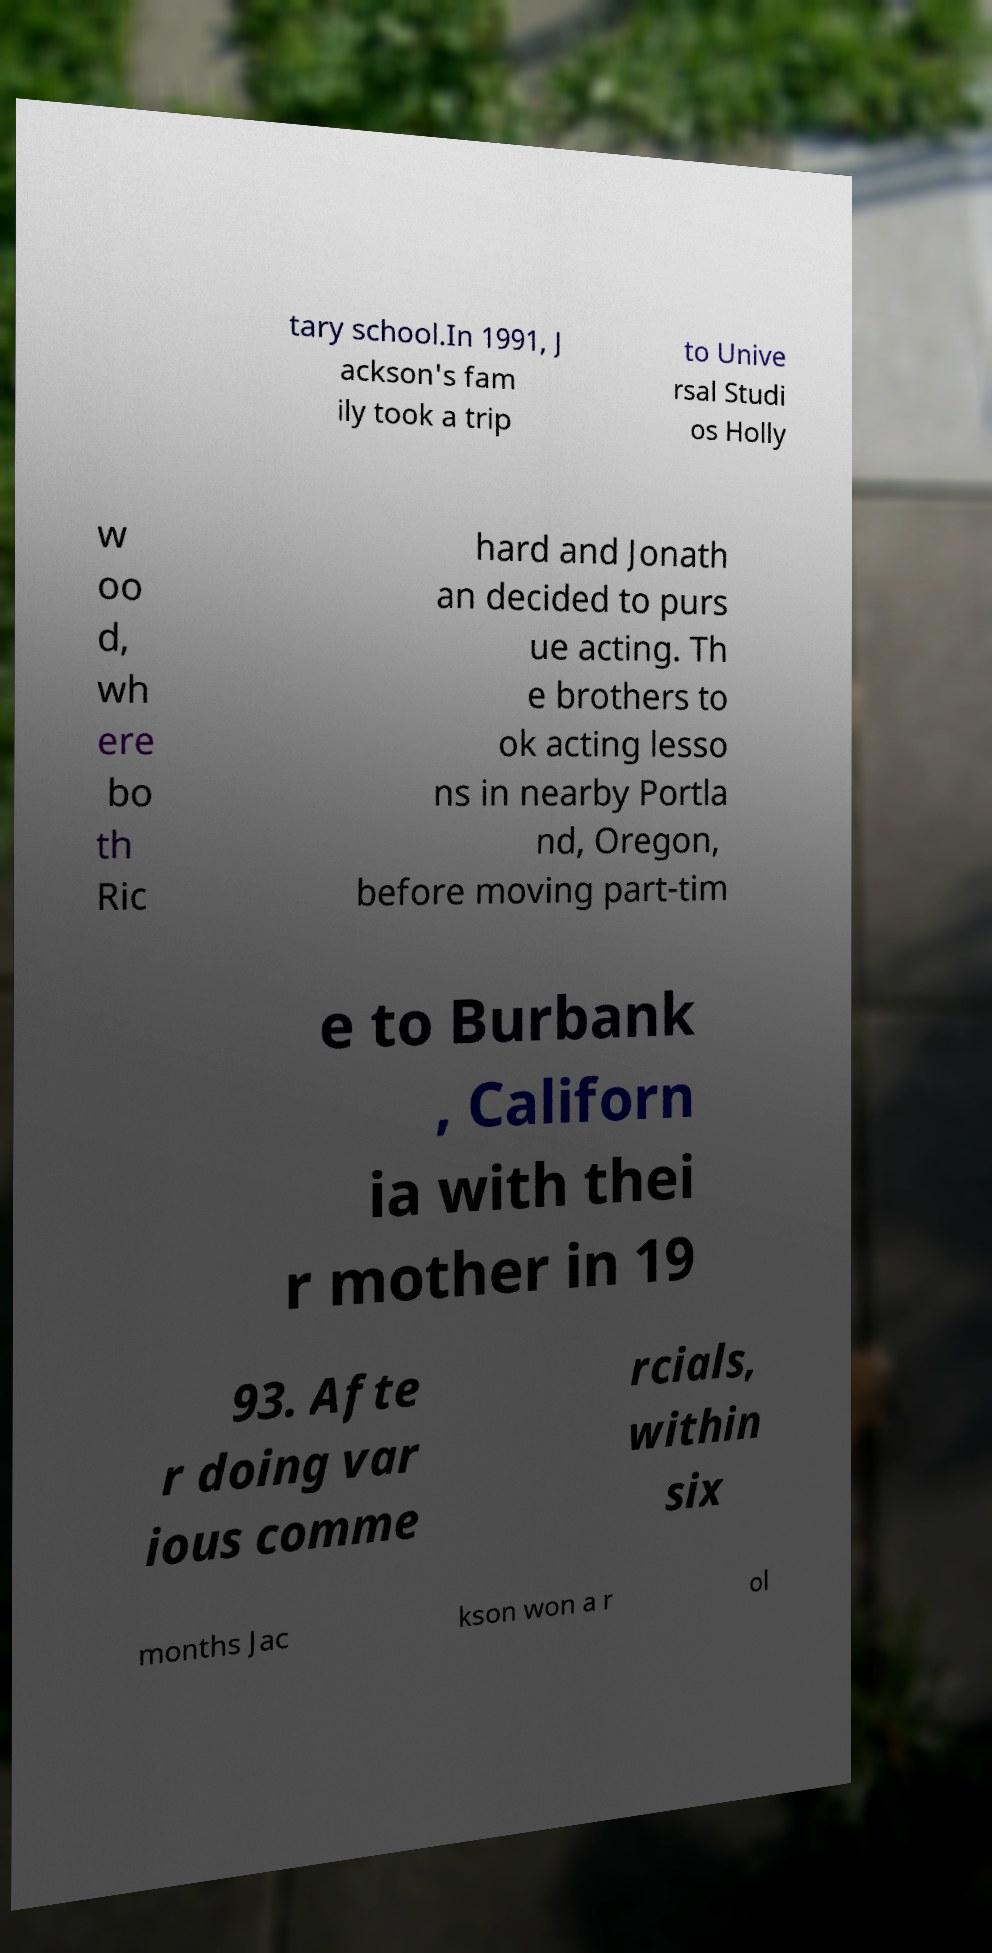Can you read and provide the text displayed in the image?This photo seems to have some interesting text. Can you extract and type it out for me? tary school.In 1991, J ackson's fam ily took a trip to Unive rsal Studi os Holly w oo d, wh ere bo th Ric hard and Jonath an decided to purs ue acting. Th e brothers to ok acting lesso ns in nearby Portla nd, Oregon, before moving part-tim e to Burbank , Californ ia with thei r mother in 19 93. Afte r doing var ious comme rcials, within six months Jac kson won a r ol 